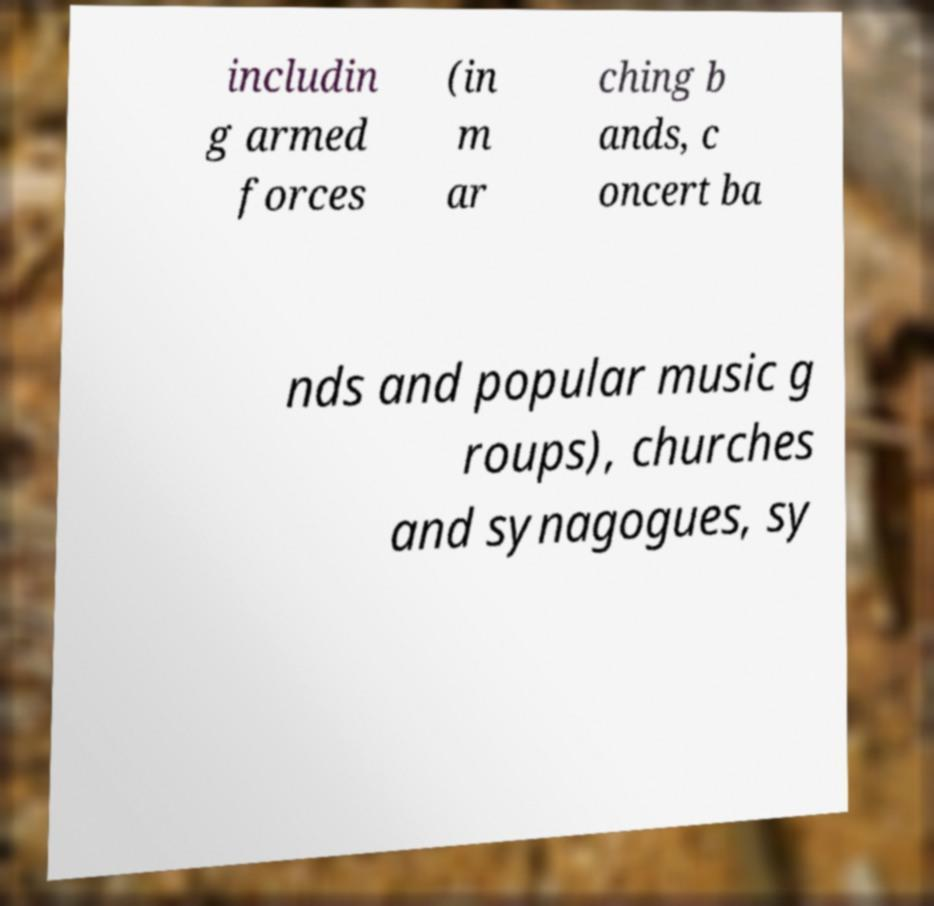There's text embedded in this image that I need extracted. Can you transcribe it verbatim? includin g armed forces (in m ar ching b ands, c oncert ba nds and popular music g roups), churches and synagogues, sy 